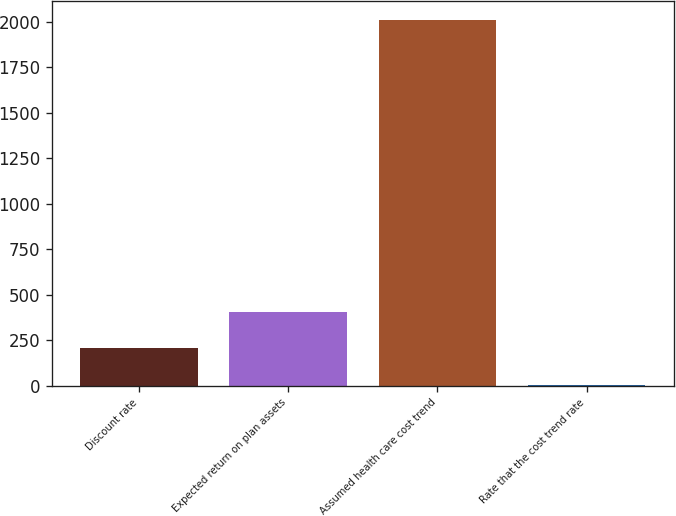Convert chart. <chart><loc_0><loc_0><loc_500><loc_500><bar_chart><fcel>Discount rate<fcel>Expected return on plan assets<fcel>Assumed health care cost trend<fcel>Rate that the cost trend rate<nl><fcel>205.6<fcel>406.2<fcel>2011<fcel>5<nl></chart> 